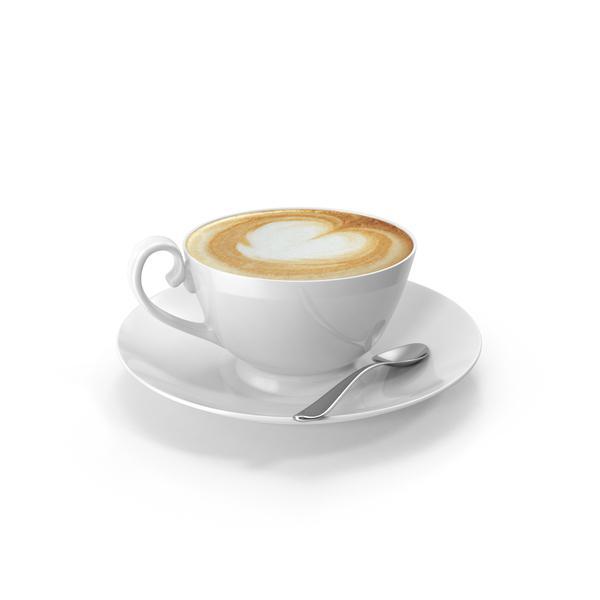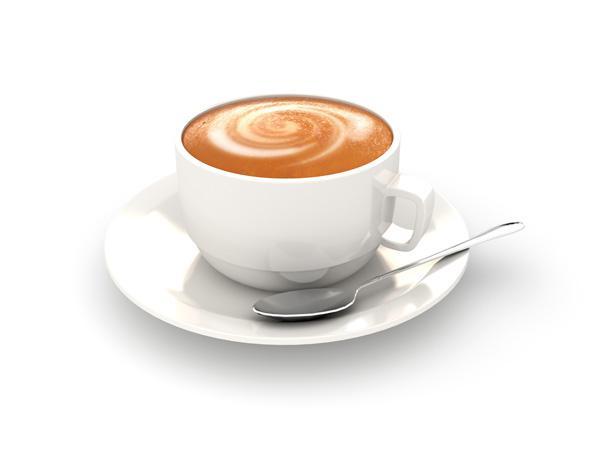The first image is the image on the left, the second image is the image on the right. Examine the images to the left and right. Is the description "In one image, there is no spoon laid next to the cup on the plate." accurate? Answer yes or no. No. The first image is the image on the left, the second image is the image on the right. Given the left and right images, does the statement "Full cups of coffee sit on matching saucers with a spoon." hold true? Answer yes or no. Yes. 